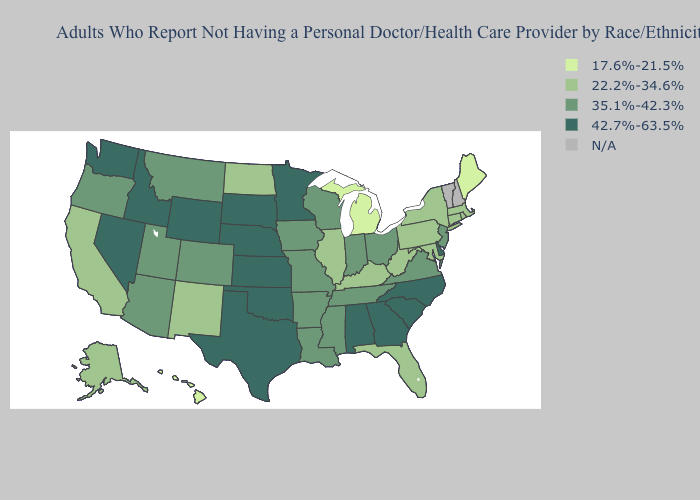Which states have the highest value in the USA?
Write a very short answer. Alabama, Delaware, Georgia, Idaho, Kansas, Minnesota, Nebraska, Nevada, North Carolina, Oklahoma, South Carolina, South Dakota, Texas, Washington, Wyoming. What is the highest value in the Northeast ?
Answer briefly. 35.1%-42.3%. Which states hav the highest value in the South?
Give a very brief answer. Alabama, Delaware, Georgia, North Carolina, Oklahoma, South Carolina, Texas. What is the value of Colorado?
Write a very short answer. 35.1%-42.3%. Is the legend a continuous bar?
Give a very brief answer. No. Name the states that have a value in the range 22.2%-34.6%?
Keep it brief. Alaska, California, Connecticut, Florida, Illinois, Kentucky, Maryland, Massachusetts, New Mexico, New York, North Dakota, Pennsylvania, Rhode Island, West Virginia. Among the states that border Massachusetts , which have the highest value?
Answer briefly. Connecticut, New York, Rhode Island. Name the states that have a value in the range 22.2%-34.6%?
Be succinct. Alaska, California, Connecticut, Florida, Illinois, Kentucky, Maryland, Massachusetts, New Mexico, New York, North Dakota, Pennsylvania, Rhode Island, West Virginia. Which states have the lowest value in the South?
Be succinct. Florida, Kentucky, Maryland, West Virginia. Name the states that have a value in the range N/A?
Write a very short answer. New Hampshire, Vermont. What is the value of Nevada?
Concise answer only. 42.7%-63.5%. What is the value of Idaho?
Concise answer only. 42.7%-63.5%. Which states have the lowest value in the USA?
Give a very brief answer. Hawaii, Maine, Michigan. Name the states that have a value in the range 17.6%-21.5%?
Short answer required. Hawaii, Maine, Michigan. Does Delaware have the lowest value in the USA?
Concise answer only. No. 